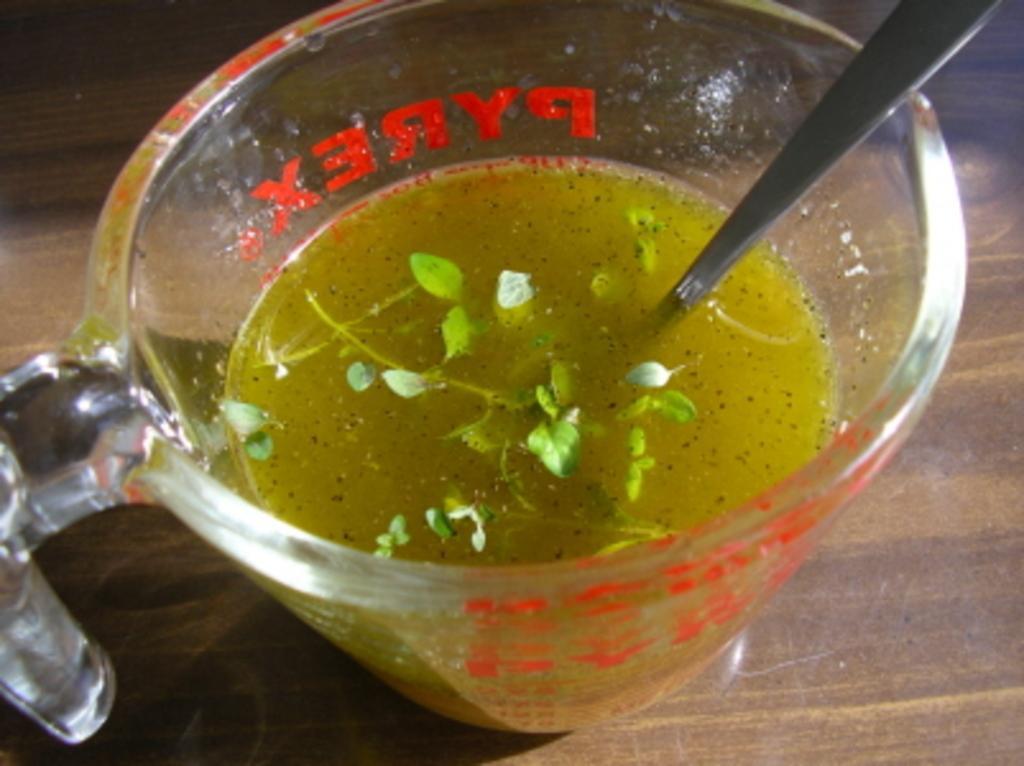Describe this image in one or two sentences. In this picture I can observe a cup. There is some drink in the cup. I can observe some leaves and spoon in the drink. The cup is placed on the brown color table. 